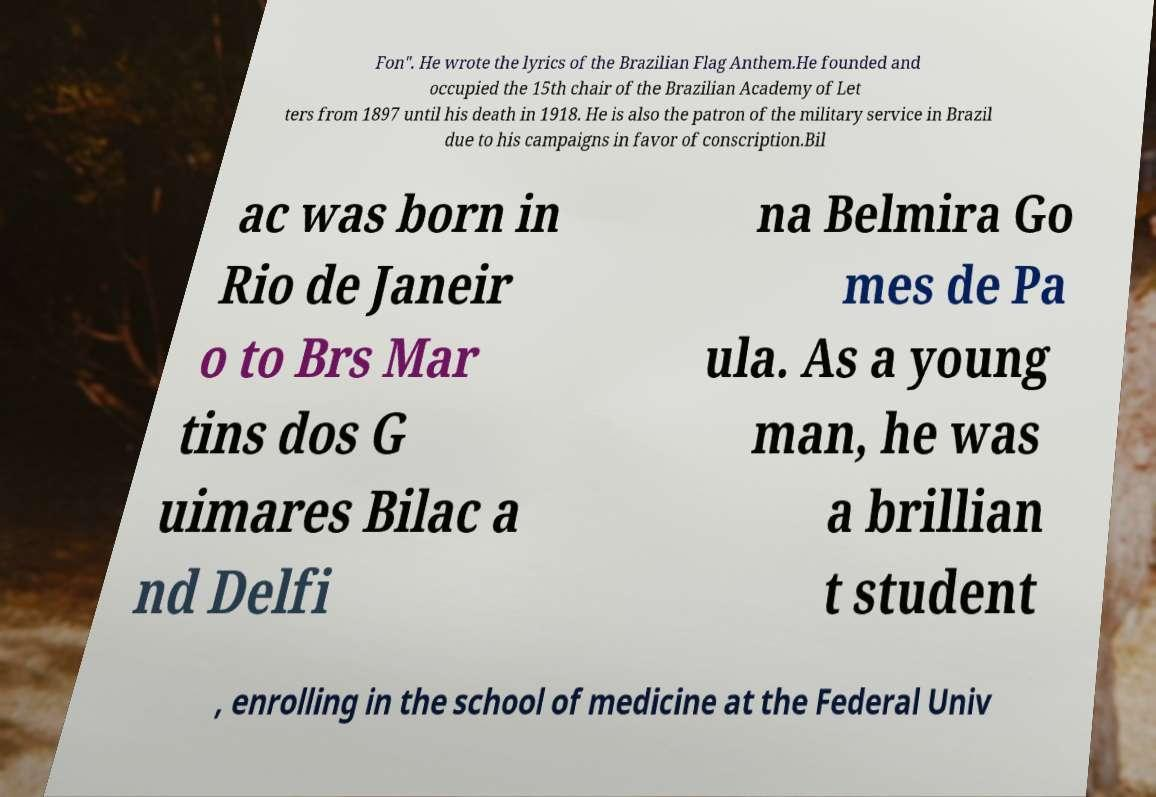There's text embedded in this image that I need extracted. Can you transcribe it verbatim? Fon". He wrote the lyrics of the Brazilian Flag Anthem.He founded and occupied the 15th chair of the Brazilian Academy of Let ters from 1897 until his death in 1918. He is also the patron of the military service in Brazil due to his campaigns in favor of conscription.Bil ac was born in Rio de Janeir o to Brs Mar tins dos G uimares Bilac a nd Delfi na Belmira Go mes de Pa ula. As a young man, he was a brillian t student , enrolling in the school of medicine at the Federal Univ 